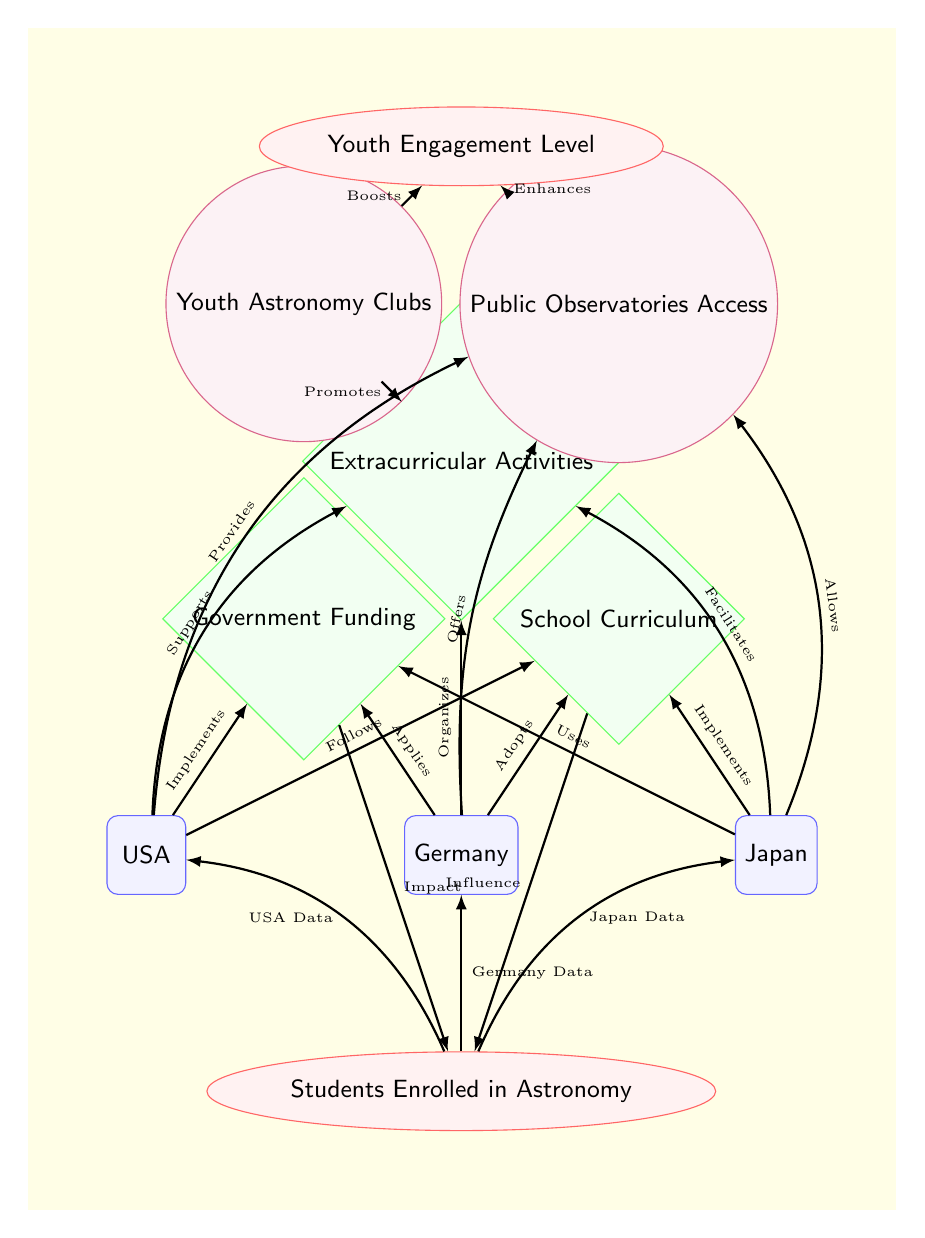What countries implement government funding for astronomy education? The diagram shows that the USA, Germany, and Japan all implement government funding as a policy for astronomy education. This can be determined by observing the nodes and edges connecting each country to the "Government Funding" policy.
Answer: USA, Germany, Japan How many types of policies are displayed in this diagram? The diagram includes three types of policies: Government Funding, School Curriculum, and Extracurricular Activities. This can be verified by counting the policy nodes in the diagram.
Answer: 3 What is the connection between extracurricular activities and youth astronomy clubs? The diagram indicates that "Extracurricular Activities" promotes "Youth Astronomy Clubs". This relationship is represented as a directed edge from the extracurricular policy to the clubs engagement node.
Answer: Promotes Which country offers public observatories access as part of their astronomy educational policy? According to the diagram, all three countries (USA, Germany, and Japan) allow access to public observatories, as indicated by the edges from each country to the observatories engagement node.
Answer: USA, Germany, Japan What is the ultimate effect of the school curriculum on students enrolled in astronomy? The diagram illustrates that the school curriculum has an influence on students enrolled in astronomy, indicated by a directed edge leading from the curriculum policy to the enrolled metrics node.
Answer: Influence Which engagement option is boosted by youth astronomy clubs? The diagram specifies that youth astronomy clubs boost the youth engagement level, shown by a directed edge from the clubs to the engagement metrics node.
Answer: Boosts What is the highest level of youth engagement indicated in the diagram? The diagram does not provide specific numerical values for youth engagement; however, it categorically indicates different engagement pathways leading to an enhanced youth engagement level resulting from policies and activities shown. Therefore, the answer is more about the relationship depicted rather than a specific number.
Answer: Enhanced Which country is connected to the Metrics node labeled “Students Enrolled in Astronomy”? The diagram reveals that all three countries connect to the “Students Enrolled in Astronomy” metrics node through respective data edges. Therefore, the answer includes all the countries shown.
Answer: USA, Germany, Japan What type of engagement is linked to public observatories access? The diagram indicates that access to public observatories enhances the youth engagement level, as shown by the directed edge going from the observatories node to the engagement metrics node.
Answer: Enhances 